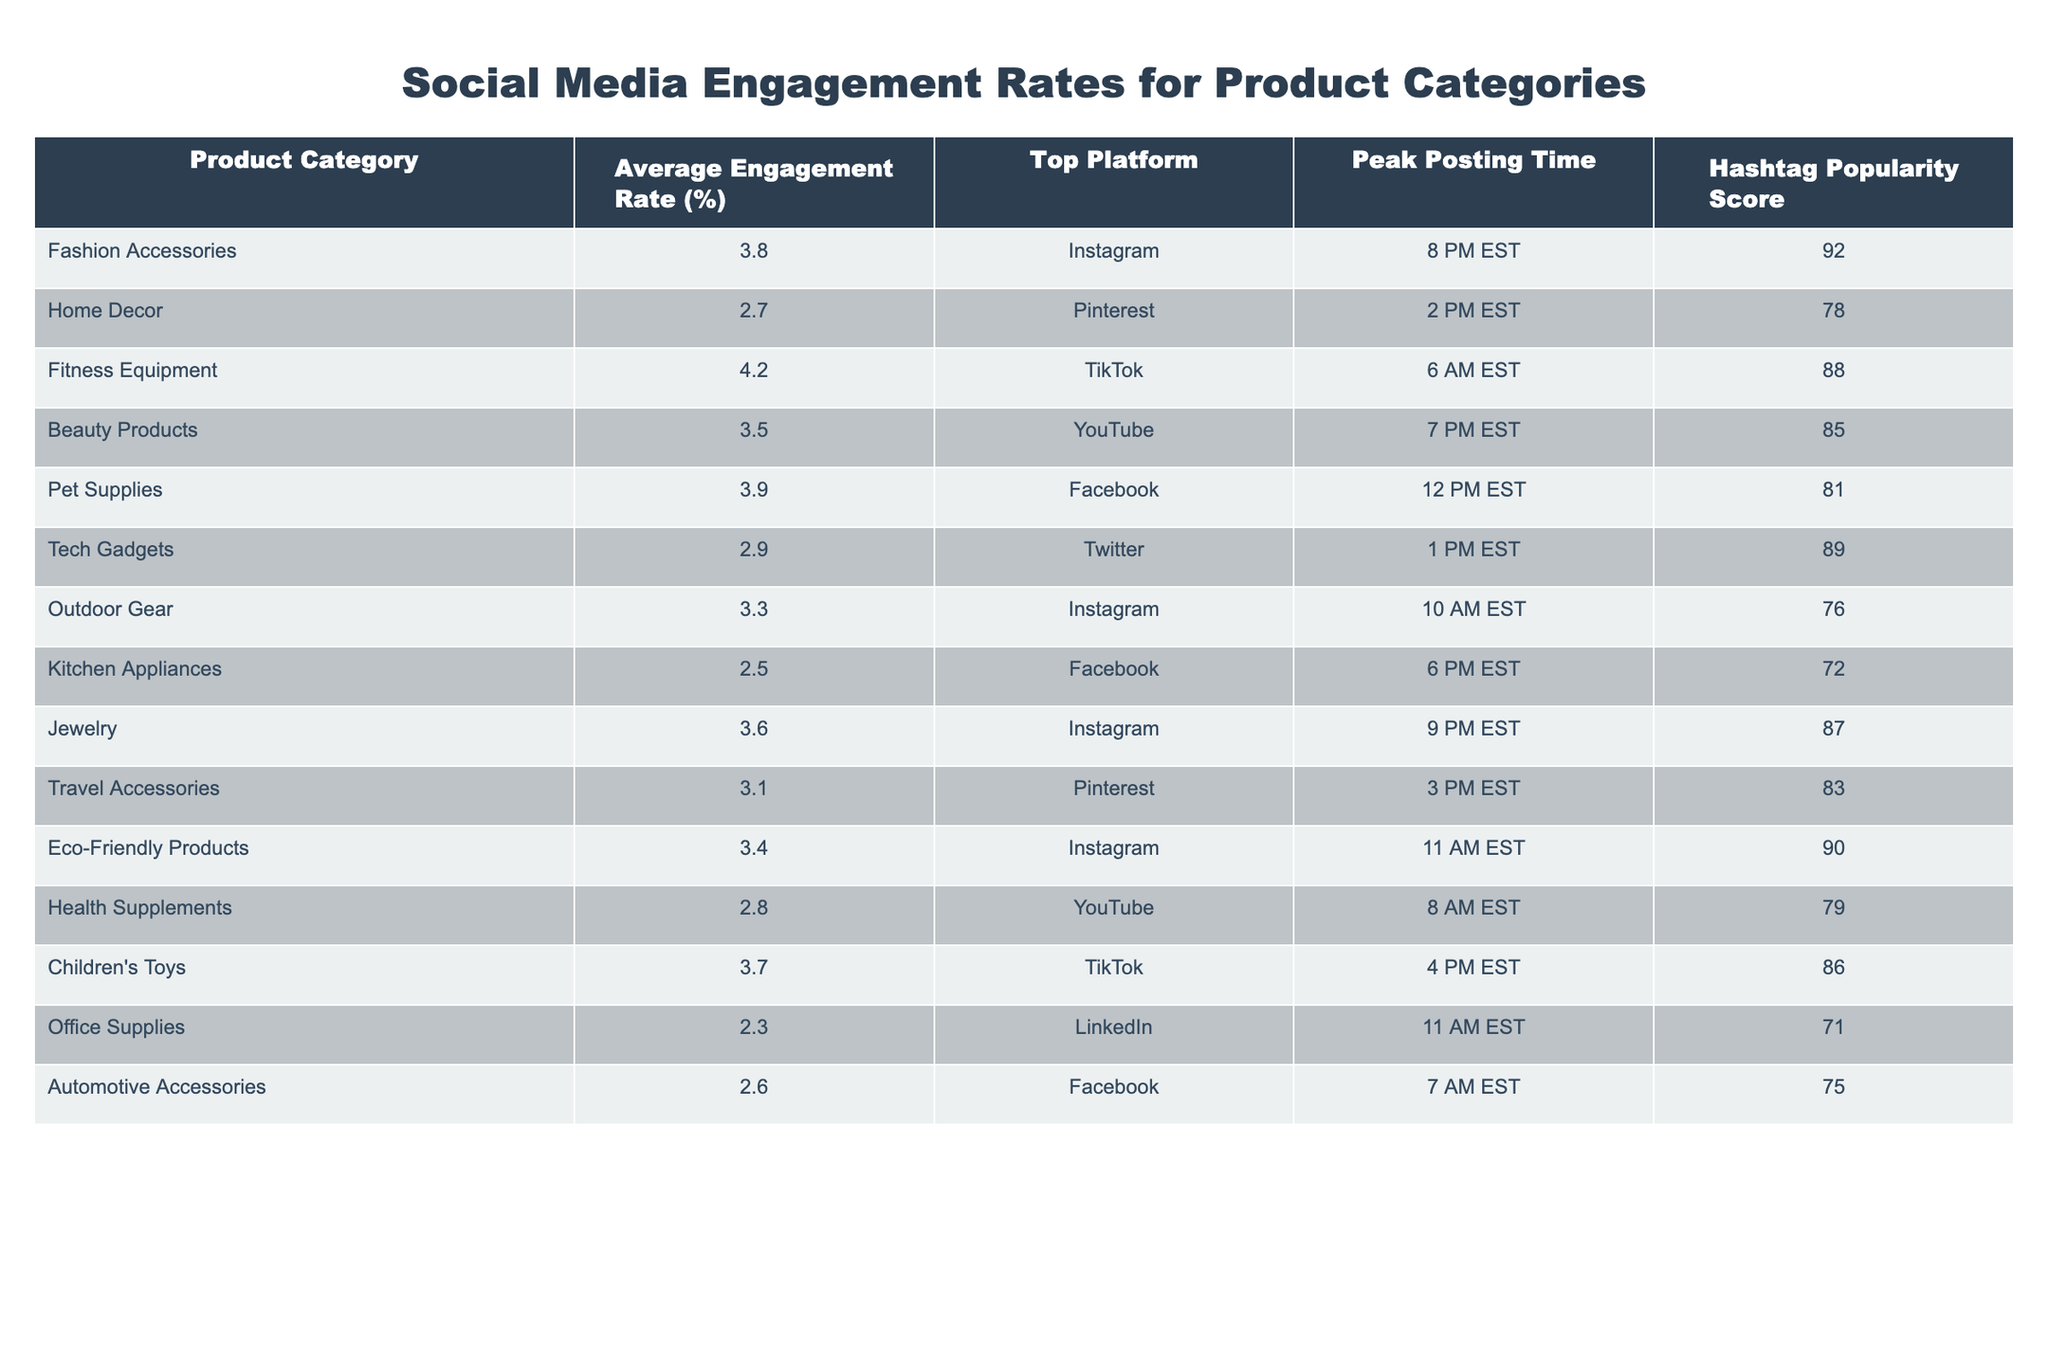What is the average engagement rate for Beauty Products? The table shows that the average engagement rate for Beauty Products is 3.5%.
Answer: 3.5% Which product category has the highest average engagement rate? Fitness Equipment has the highest average engagement rate at 4.2%.
Answer: 4.2% What platform is most commonly associated with Fashion Accessories? The table indicates that Instagram is the top platform for Fashion Accessories.
Answer: Instagram Is the average engagement rate for Pet Supplies higher than that for Home Decor? Pet Supplies has an average engagement rate of 3.9%, while Home Decor has 2.7%. Therefore, it is true that the average engagement rate for Pet Supplies is higher.
Answer: Yes What is the average engagement rate for products categorized under Fitness Equipment and Children's Toys combined? The average engagement rates are 4.2% for Fitness Equipment and 3.7% for Children's Toys. The sum is 4.2 + 3.7 = 7.9 and dividing by 2 gives us an average of 3.95%.
Answer: 3.95% Does Tech Gadgets have a higher engagement rate than Kitchen Appliances? Tech Gadgets has an engagement rate of 2.9% while Kitchen Appliances has an engagement rate of 2.5%, which means Tech Gadgets has a higher rate.
Answer: Yes Which product category has the lowest engagement rate and what is it? The lowest engagement rate is for Office Supplies at 2.3%.
Answer: Office Supplies, 2.3% How does the average engagement rate of Eco-Friendly Products compare to that of Automotive Accessories? Eco-Friendly Products has an engagement rate of 3.4% while Automotive Accessories has 2.6%. Comparing the two, Eco-Friendly Products has a higher engagement rate.
Answer: Eco-Friendly Products has a higher rate What is the peak posting time for Jewelry and how does it compare to that of Fitness Equipment? Jewelry's peak posting time is 9 PM EST, while Fitness Equipment's is 6 AM EST. The times are different; hence, we cannot specify one as being earlier or later without additional context.
Answer: Different times Which product category has a higher hashtag popularity score: Home Decor or Outdoor Gear? Home Decor has a hashtag popularity score of 78, whereas Outdoor Gear has a score of 76, indicating that Home Decor has a higher score.
Answer: Home Decor What is the average engagement rate for all product categories in the table? Summing all average engagement rates: 3.8 + 2.7 + 4.2 + 3.5 + 3.9 + 2.9 + 3.3 + 2.5 + 3.6 + 3.1 + 3.4 + 2.8 + 3.7 + 2.3 + 2.6 = 49.7. Dividing by 15 gives us an average engagement rate of approximately 3.31%.
Answer: 3.31% 